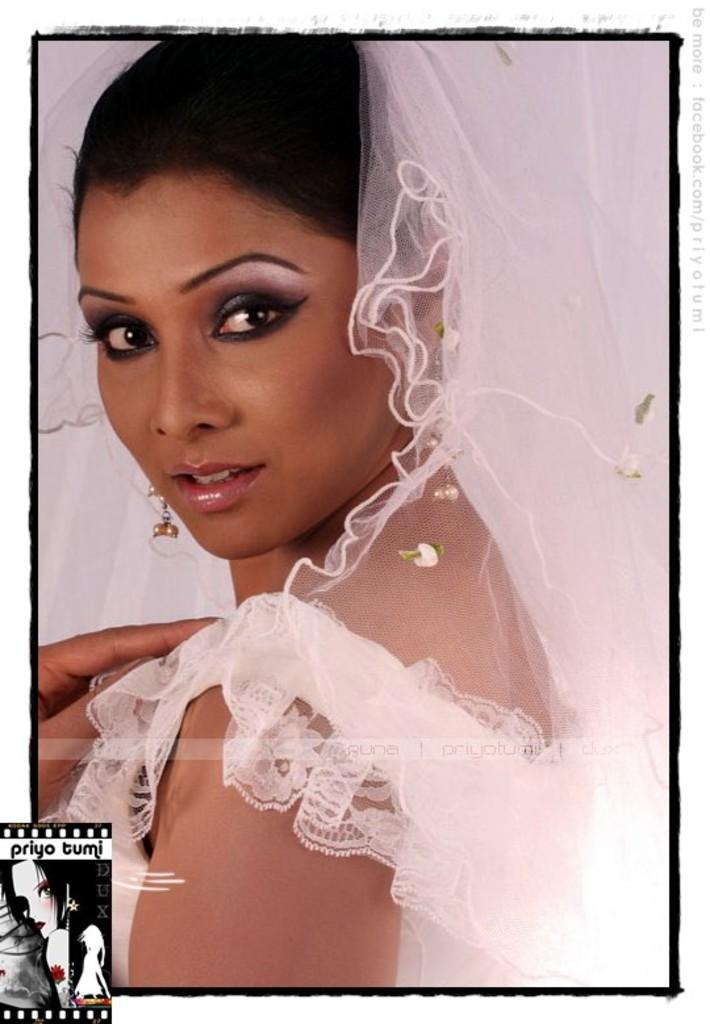Who is the main subject in the image? There is a lady in the image. What is the lady wearing? The lady is wearing a white dress. Is the lady's sister holding a whip in the image? There is no mention of a sister or a whip in the provided facts, and therefore we cannot answer this question based on the image. 